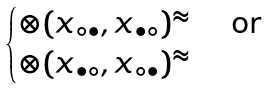Convert formula to latex. <formula><loc_0><loc_0><loc_500><loc_500>\begin{cases} \otimes ( x _ { \circ \bullet } , x _ { \bullet \circ } ) ^ { \approx } & \text { or } \\ \otimes ( x _ { \bullet \circ } , x _ { \circ \bullet } ) ^ { \approx } \end{cases}</formula> 